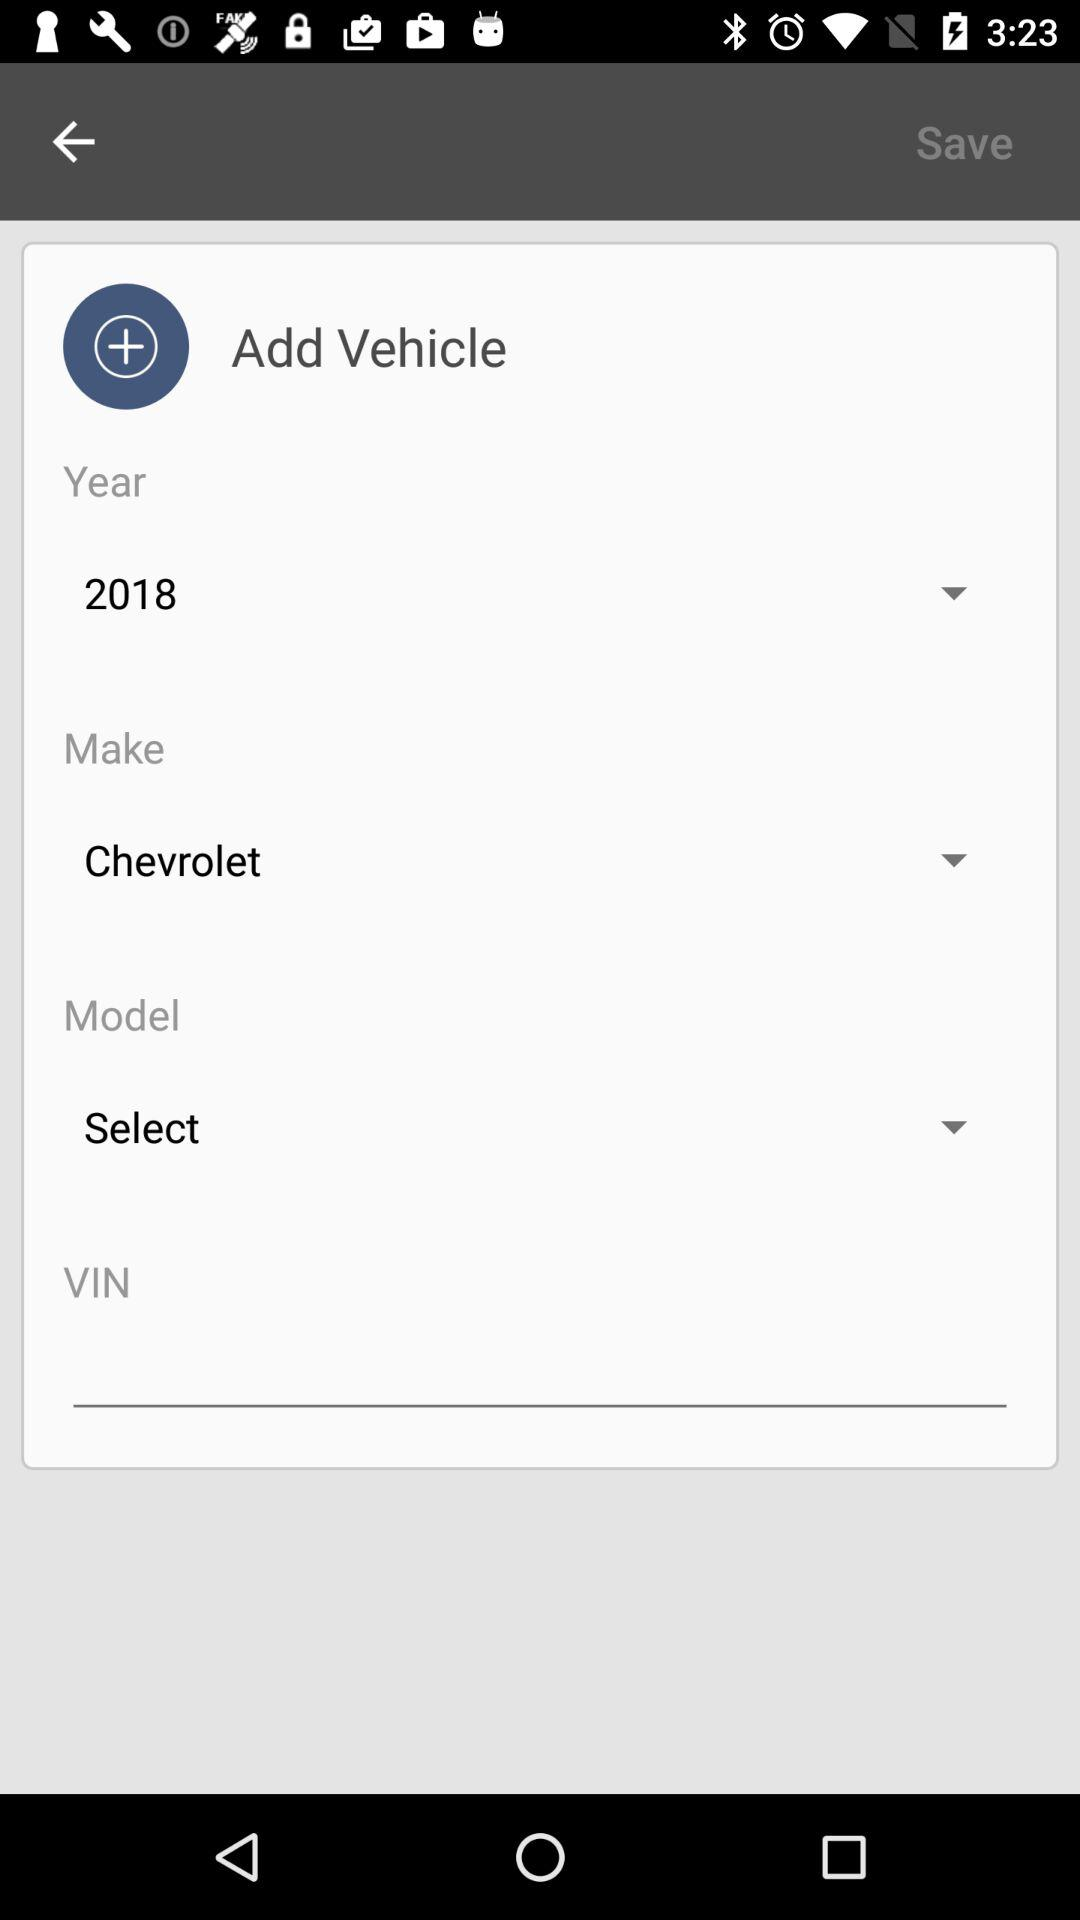What is the vehicle's VIN?
When the provided information is insufficient, respond with <no answer>. <no answer> 